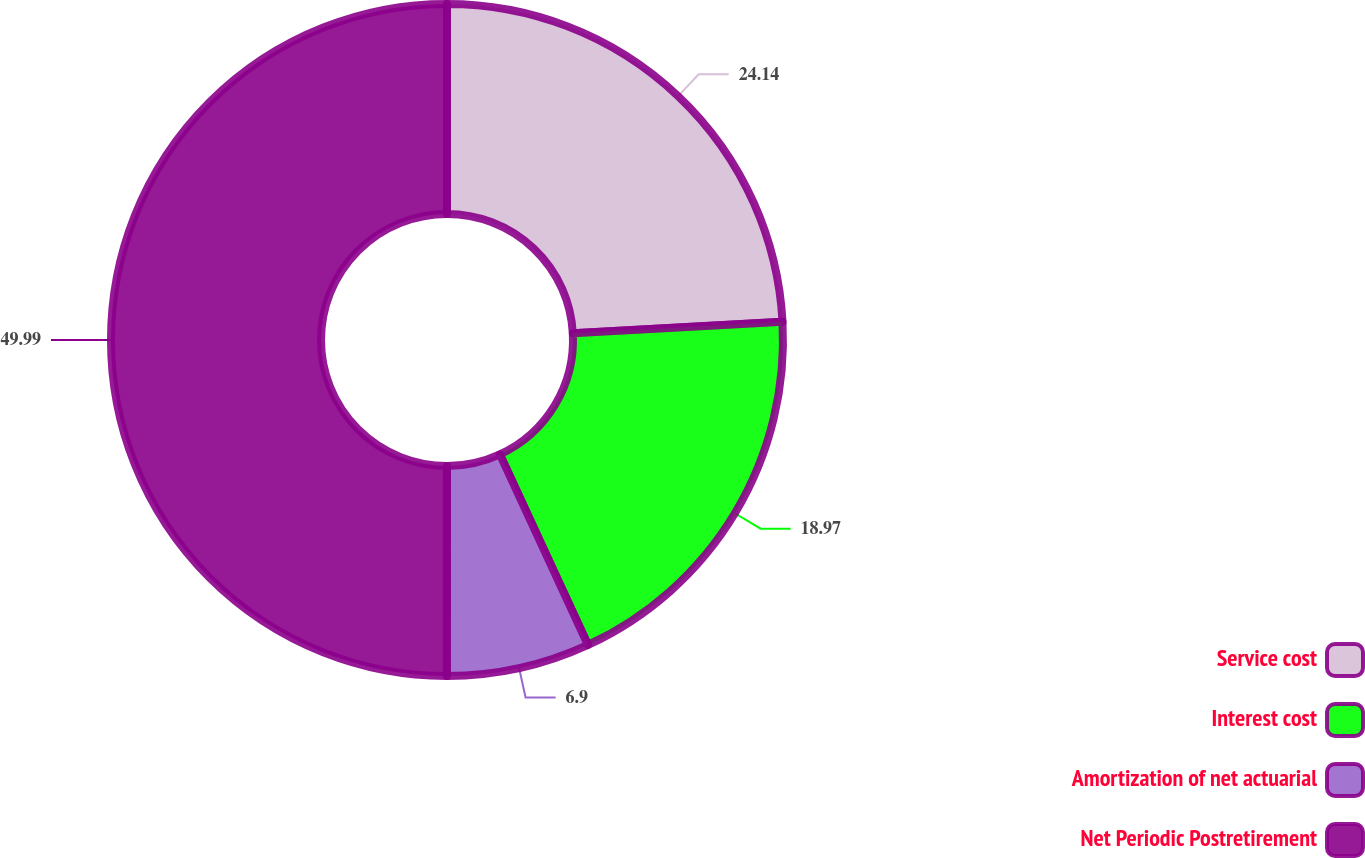Convert chart to OTSL. <chart><loc_0><loc_0><loc_500><loc_500><pie_chart><fcel>Service cost<fcel>Interest cost<fcel>Amortization of net actuarial<fcel>Net Periodic Postretirement<nl><fcel>24.14%<fcel>18.97%<fcel>6.9%<fcel>50.0%<nl></chart> 